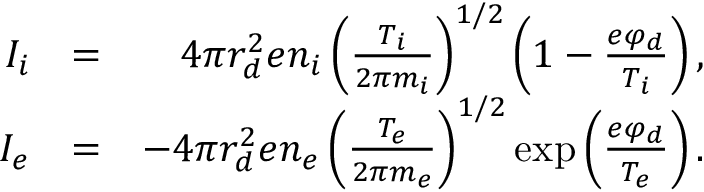Convert formula to latex. <formula><loc_0><loc_0><loc_500><loc_500>\begin{array} { r l r } { I _ { i } } & { = } & { 4 \pi r _ { d } ^ { 2 } e n _ { i } \left ( \frac { T _ { i } } { 2 \pi m _ { i } } \right ) ^ { 1 / 2 } \left ( 1 - \frac { e \varphi _ { d } } { T _ { i } } \right ) , } \\ { I _ { e } } & { = } & { - 4 \pi r _ { d } ^ { 2 } e n _ { e } \left ( \frac { T _ { e } } { 2 \pi m _ { e } } \right ) ^ { 1 / 2 } \exp \left ( \frac { e \varphi _ { d } } { T _ { e } } \right ) . } \end{array}</formula> 